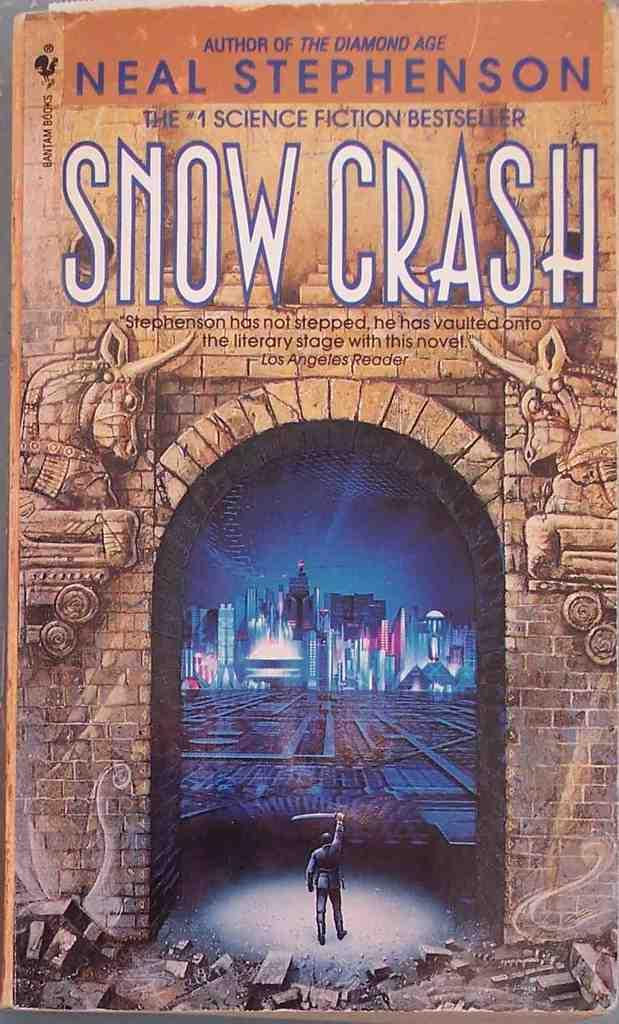<image>
Provide a brief description of the given image. Book cover with a man holding a sword written by Neal Stephenson. 